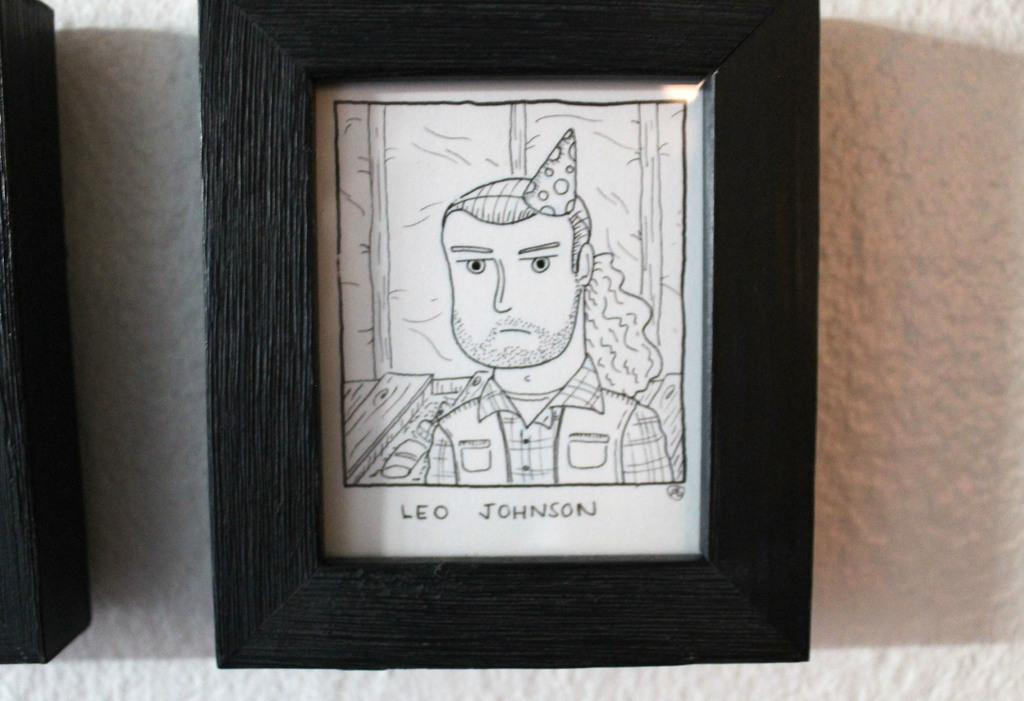Provide a one-sentence caption for the provided image. A drawing of a man in a party hat is labeled Leo Johnson. 